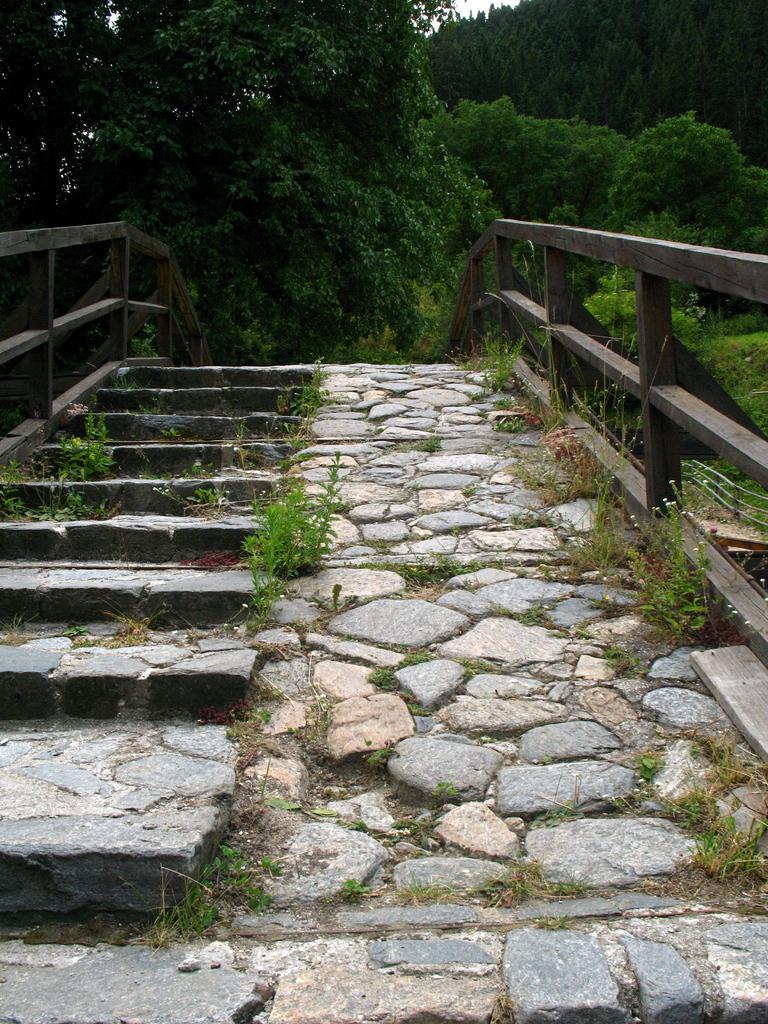Please provide a concise description of this image. In this picture we can see some trees in the background, on the left side there are stars, we can see some rocks here. 